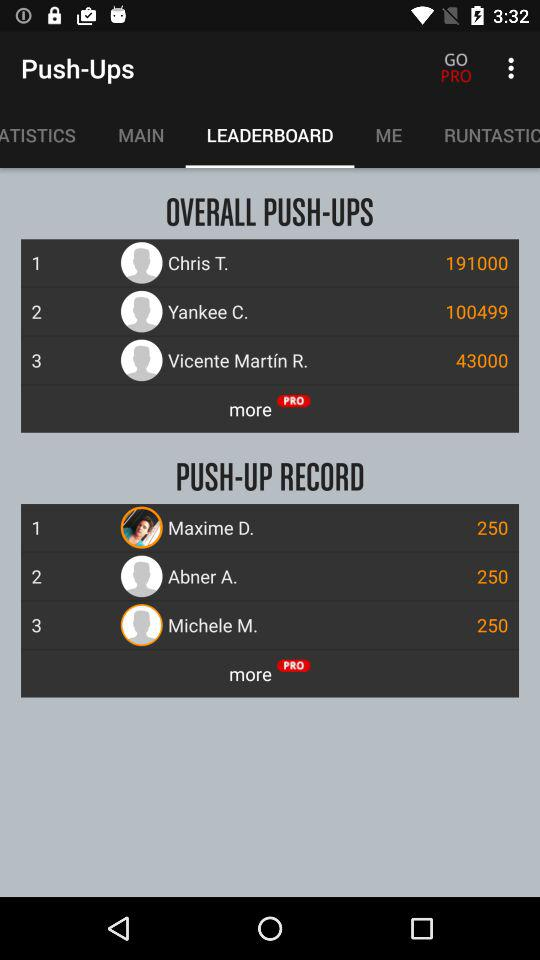On which tab am I now? You are on the "LEADERBOARD" tab. 